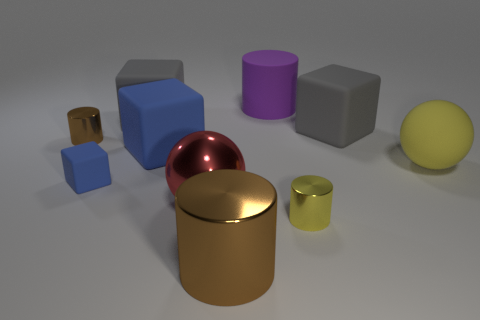What number of big things are blue rubber blocks or rubber balls?
Offer a very short reply. 2. What number of yellow objects have the same shape as the purple matte object?
Make the answer very short. 1. What is the brown cylinder that is behind the big blue object that is behind the big red thing made of?
Your answer should be compact. Metal. What is the size of the brown metal cylinder in front of the large blue block?
Make the answer very short. Large. What number of purple things are big rubber cylinders or big rubber objects?
Your answer should be very brief. 1. Is there any other thing that is made of the same material as the big red sphere?
Offer a very short reply. Yes. There is a large blue thing that is the same shape as the small rubber object; what is it made of?
Ensure brevity in your answer.  Rubber. Is the number of big brown cylinders that are in front of the small brown cylinder the same as the number of large rubber things?
Your answer should be compact. No. There is a cylinder that is right of the big metal cylinder and behind the small cube; how big is it?
Provide a short and direct response. Large. Is there anything else of the same color as the big metal sphere?
Make the answer very short. No. 